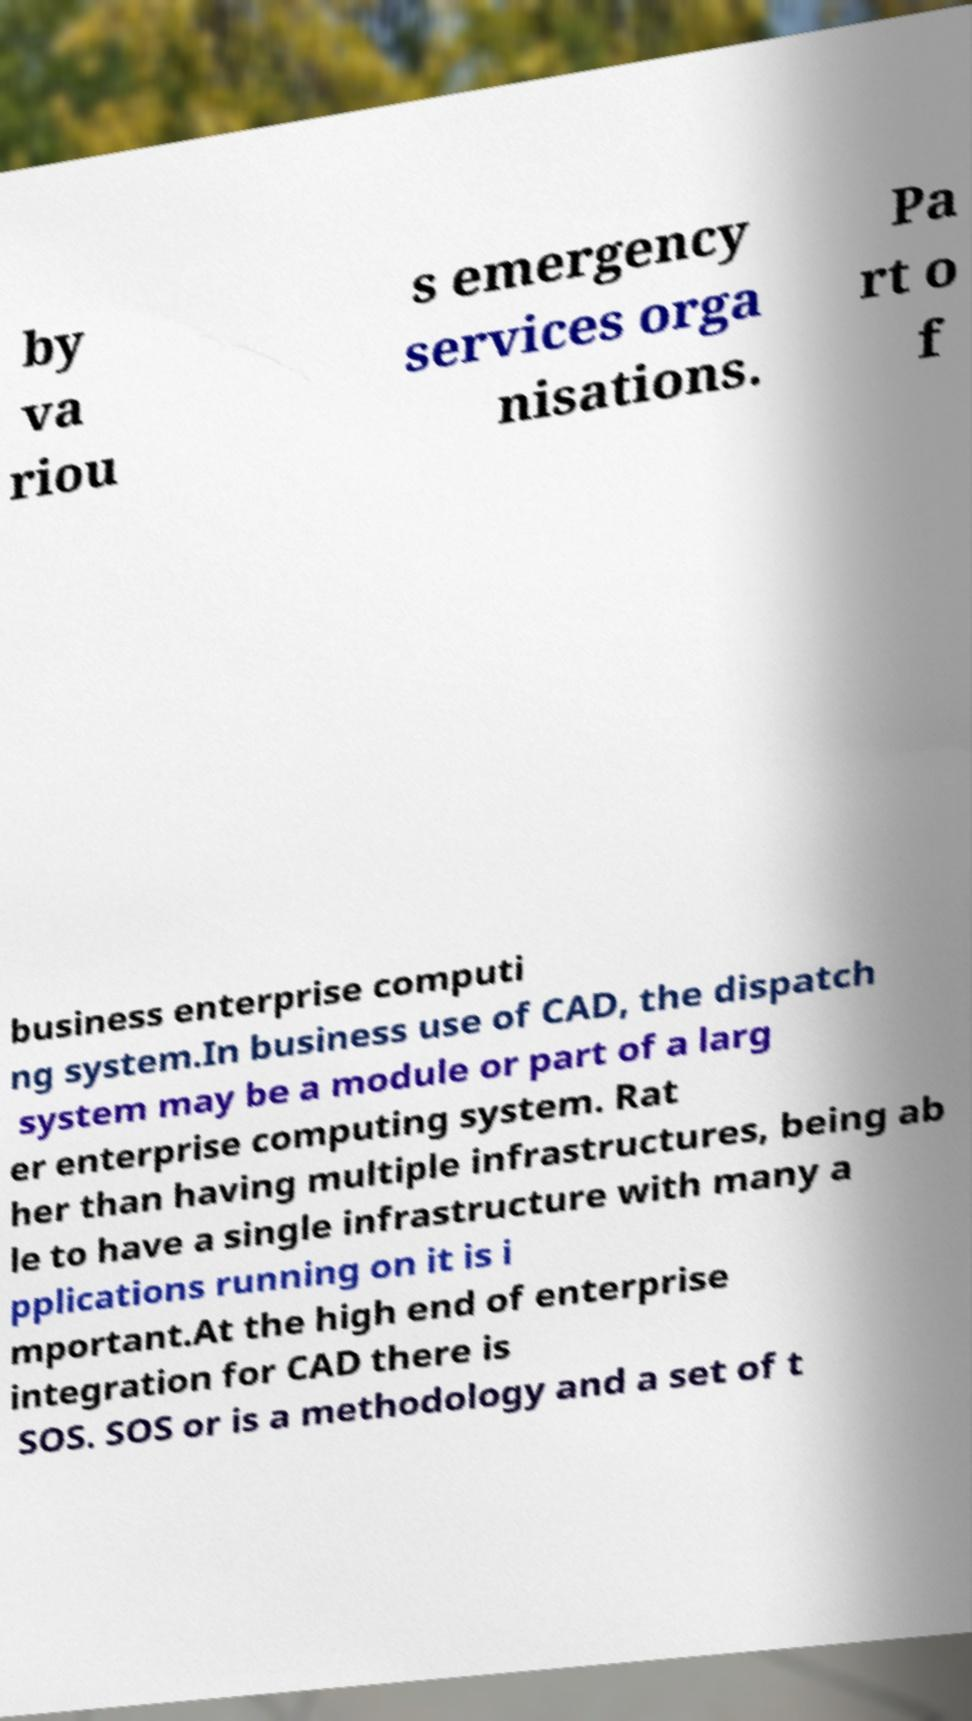Could you assist in decoding the text presented in this image and type it out clearly? by va riou s emergency services orga nisations. Pa rt o f business enterprise computi ng system.In business use of CAD, the dispatch system may be a module or part of a larg er enterprise computing system. Rat her than having multiple infrastructures, being ab le to have a single infrastructure with many a pplications running on it is i mportant.At the high end of enterprise integration for CAD there is SOS. SOS or is a methodology and a set of t 